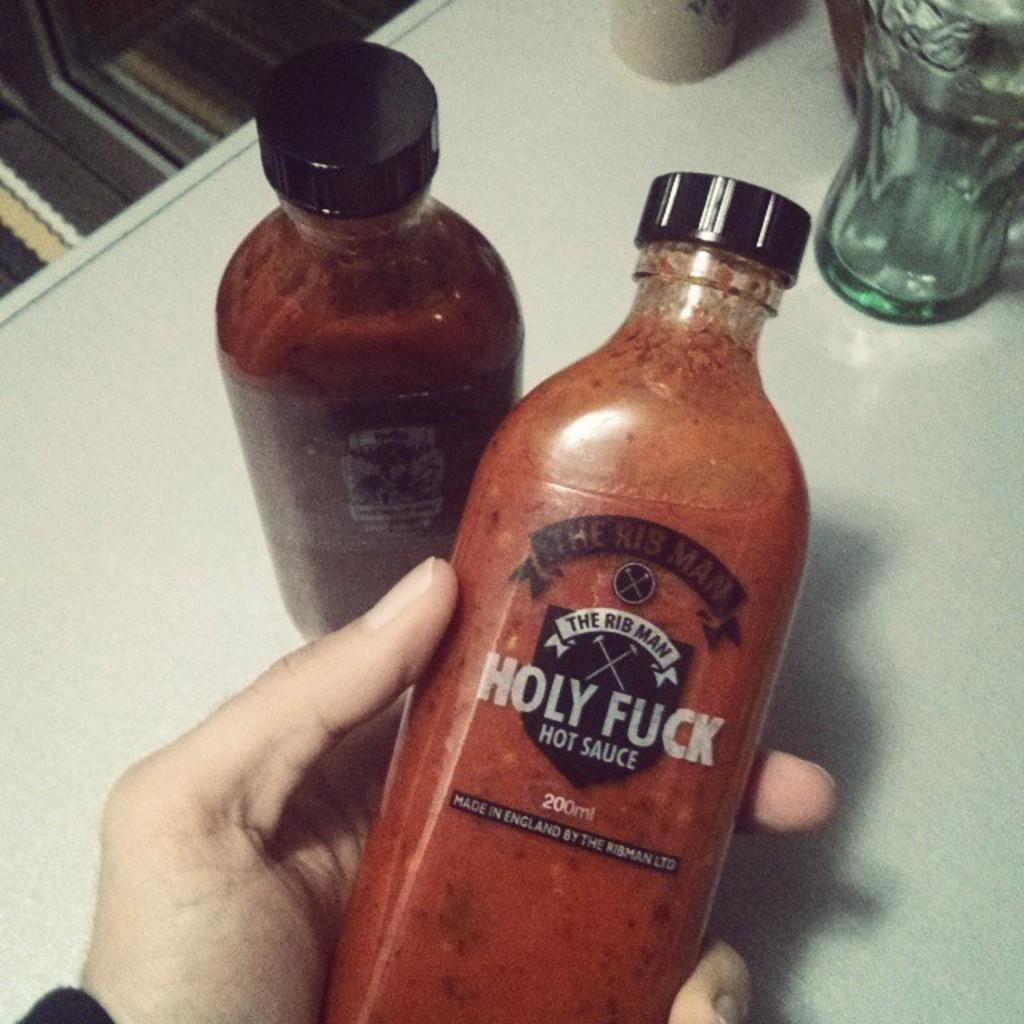<image>
Describe the image concisely. A bottle of red liquid with the words Hot Sauce on it. 